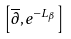<formula> <loc_0><loc_0><loc_500><loc_500>\left [ \overline { \partial } , e ^ { - L _ { \beta } } \right ]</formula> 